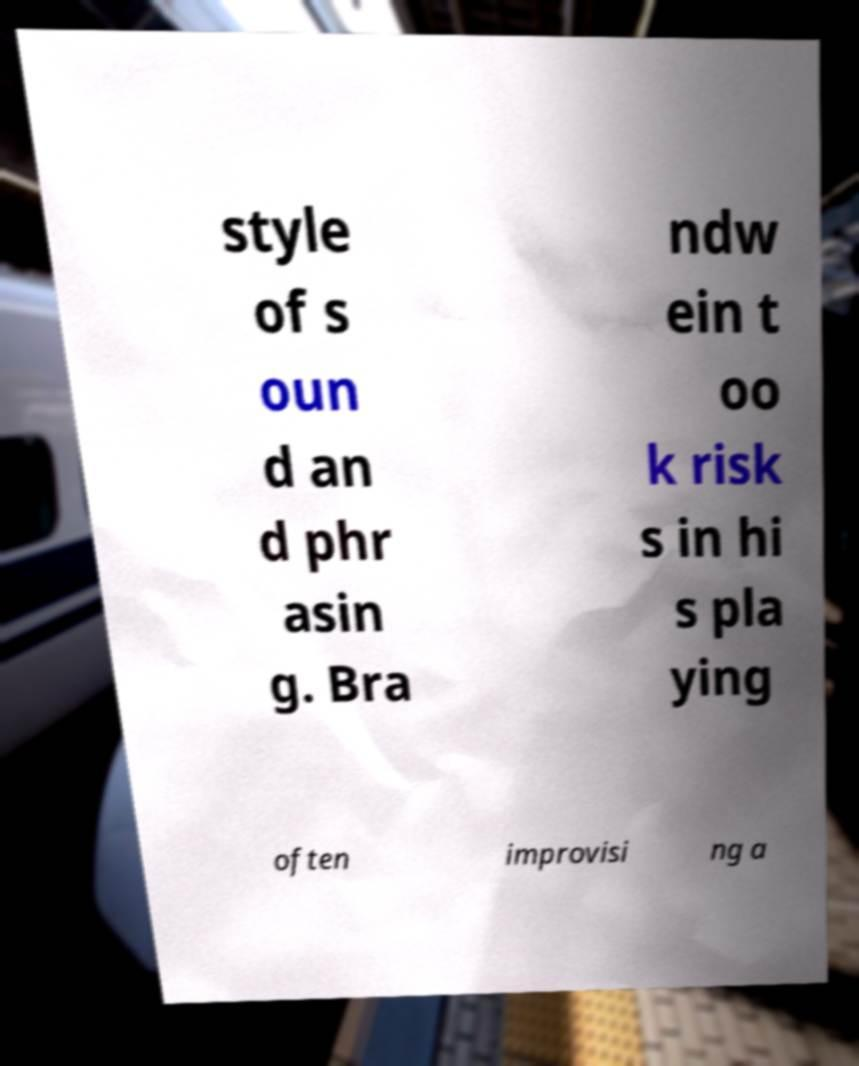I need the written content from this picture converted into text. Can you do that? style of s oun d an d phr asin g. Bra ndw ein t oo k risk s in hi s pla ying often improvisi ng a 